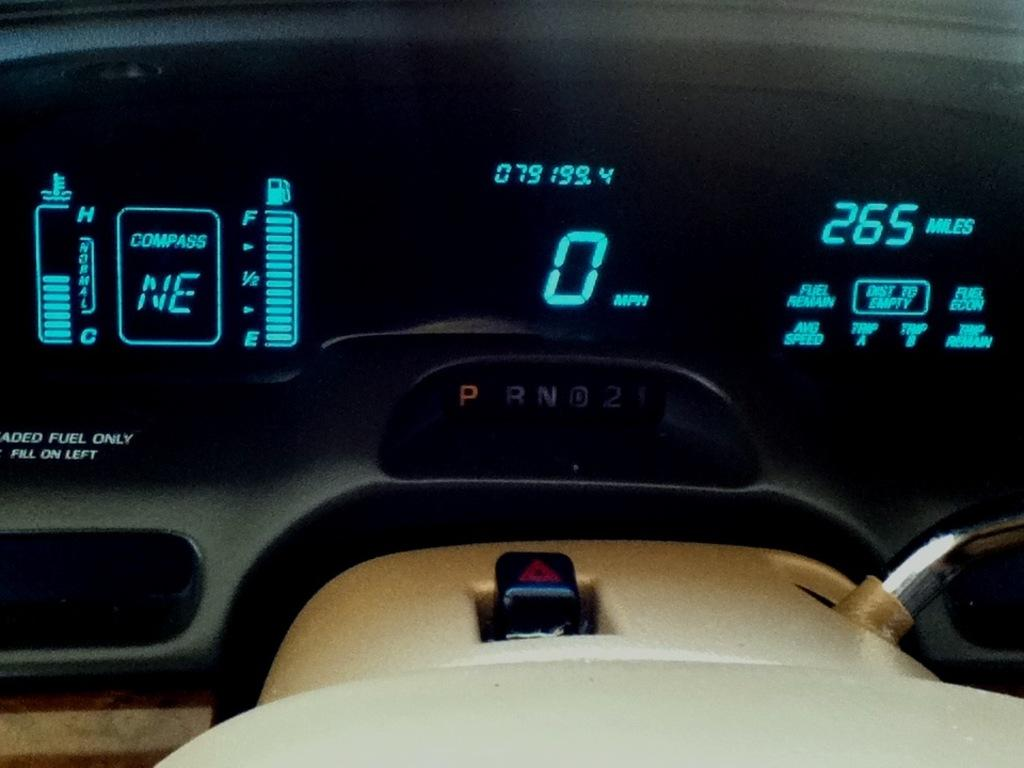What is displayed on the screen in the image? There is a screen displaying numbers and other things in the image. Can you describe the objects visible in the front of the image? Unfortunately, the provided facts do not give any information about the objects visible in the front of the image. What type of amusement can be seen in the image? There is no amusement present in the image; it only features a screen displaying numbers and other things. What is being served for dinner in the image? There is no dinner or food present in the image. 